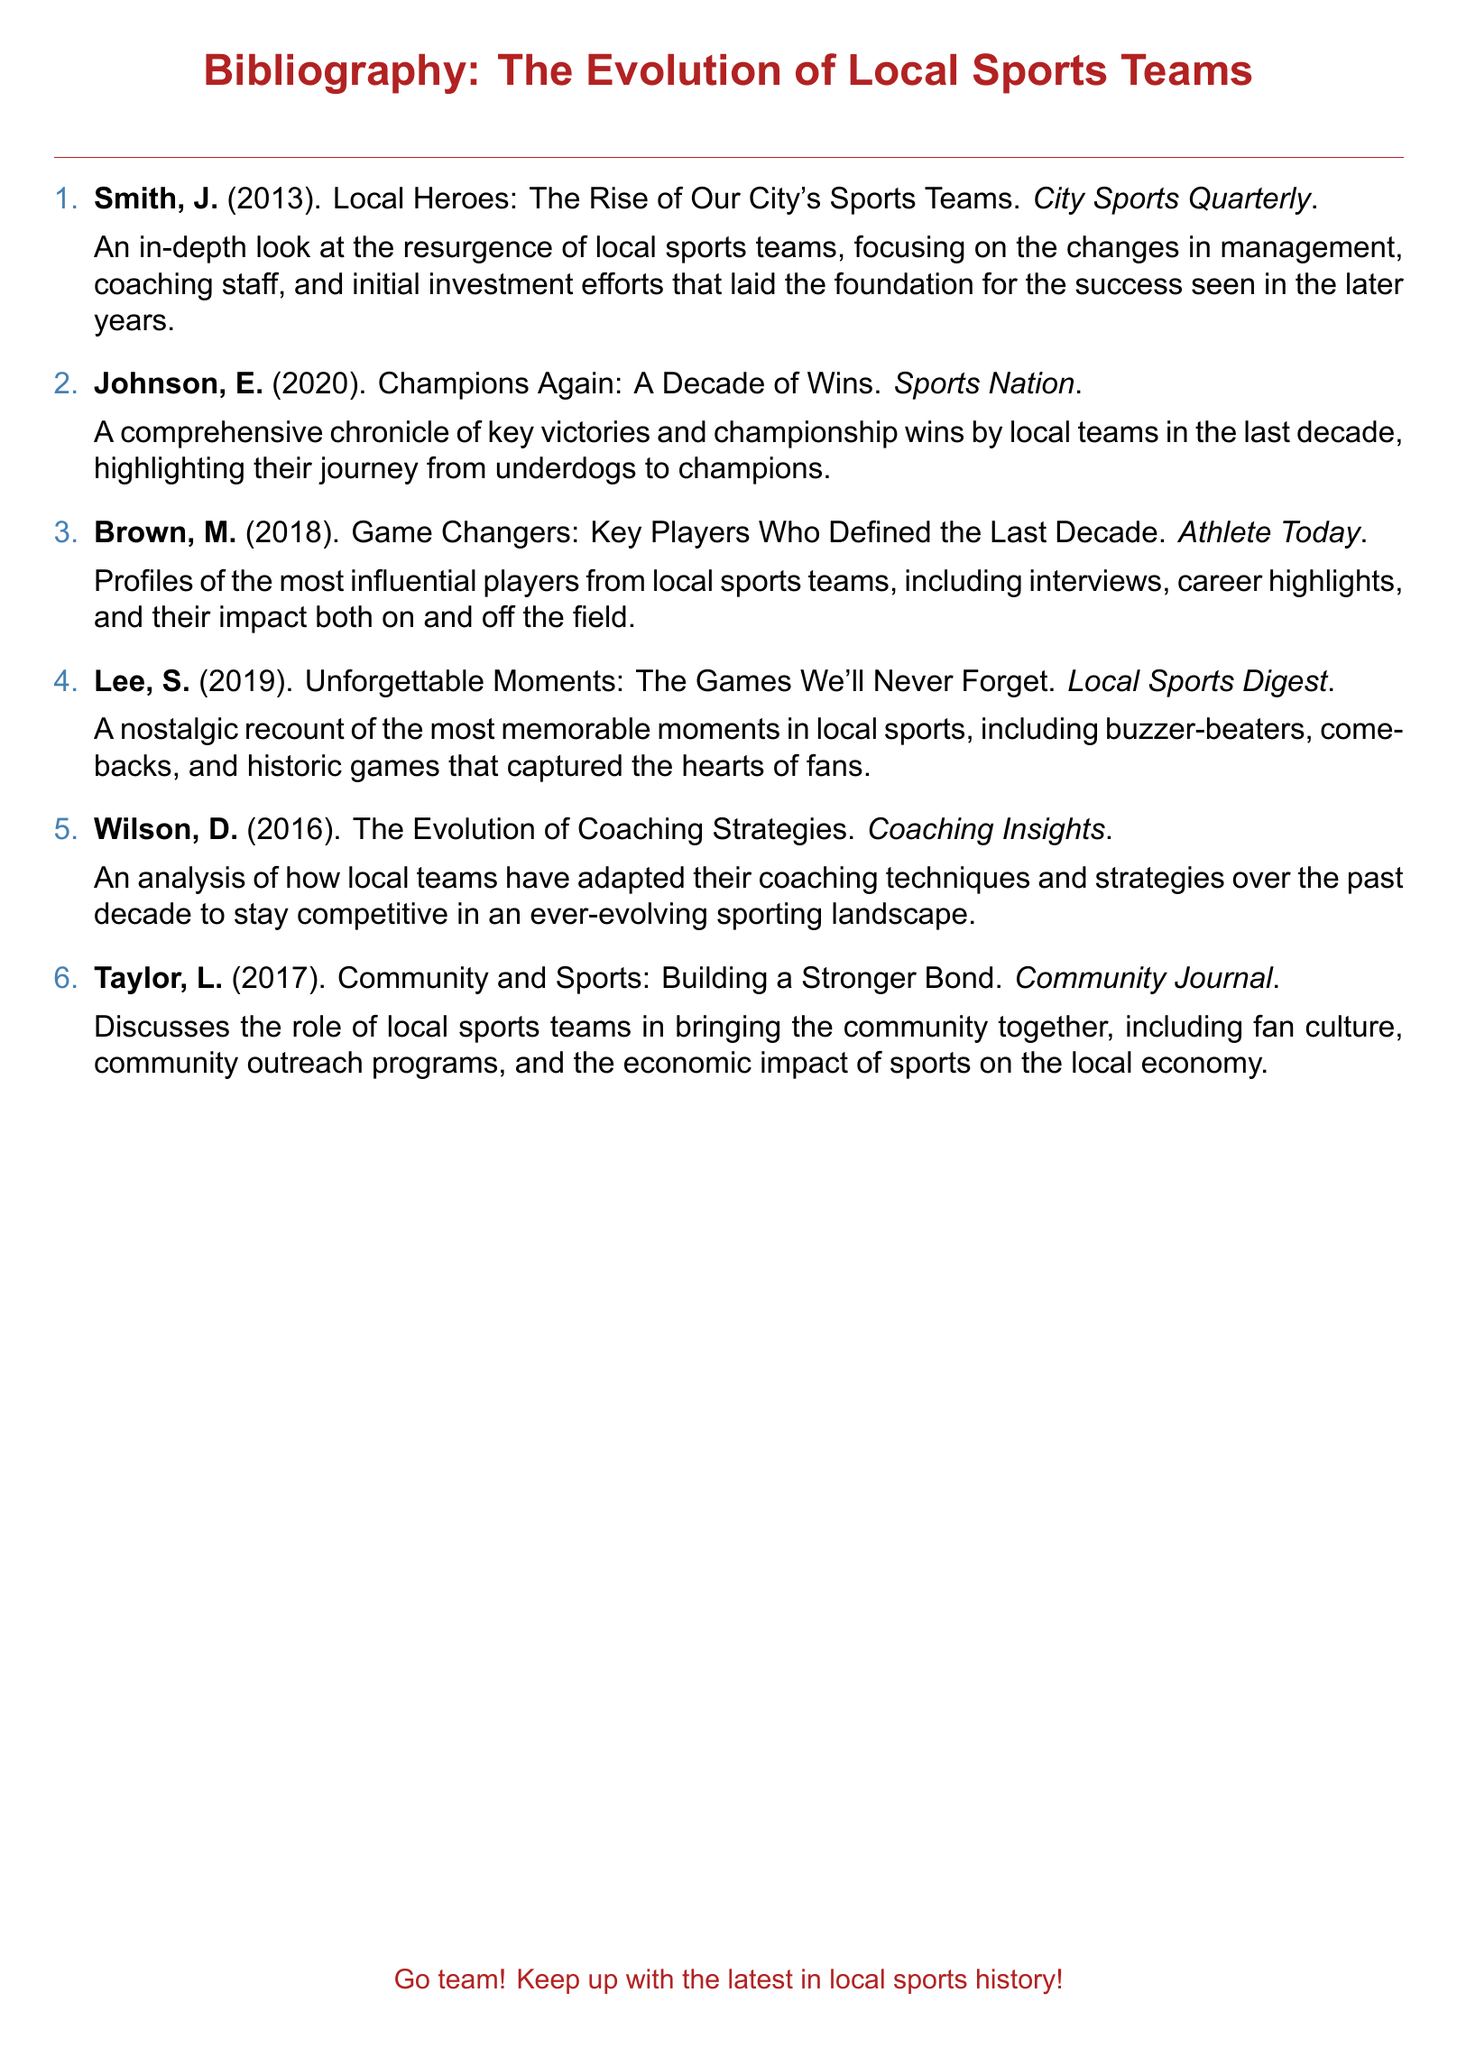What is the title of the first entry? The first entry discusses the rise of local sports teams and is titled "Local Heroes: The Rise of Our City's Sports Teams."
Answer: Local Heroes: The Rise of Our City's Sports Teams Who wrote the entry about the key players? The entry that profiles key players is authored by Brown, M.
Answer: Brown, M In what year was the entry about unforgettable moments published? The entry recounting unforgettable moments in local sports was published in 2019.
Answer: 2019 Which journal features the article on community and sports? The article discussing the bond between community and sports is published in the "Community Journal."
Answer: Community Journal How many entries discuss coaching strategies? The document contains one entry that specifically discusses coaching strategies.
Answer: One What is the main focus of Johnson, E.'s work? Johnson, E.'s work focuses on a decade of wins by local sports teams.
Answer: A decade of wins What color is used for the numbering of the entries? The entries are numbered using the color sporty blue.
Answer: Sporty blue Who is the author of the final entry in the bibliography? The final entry discussing the community impact of local sports teams is authored by Taylor, L.
Answer: Taylor, L 